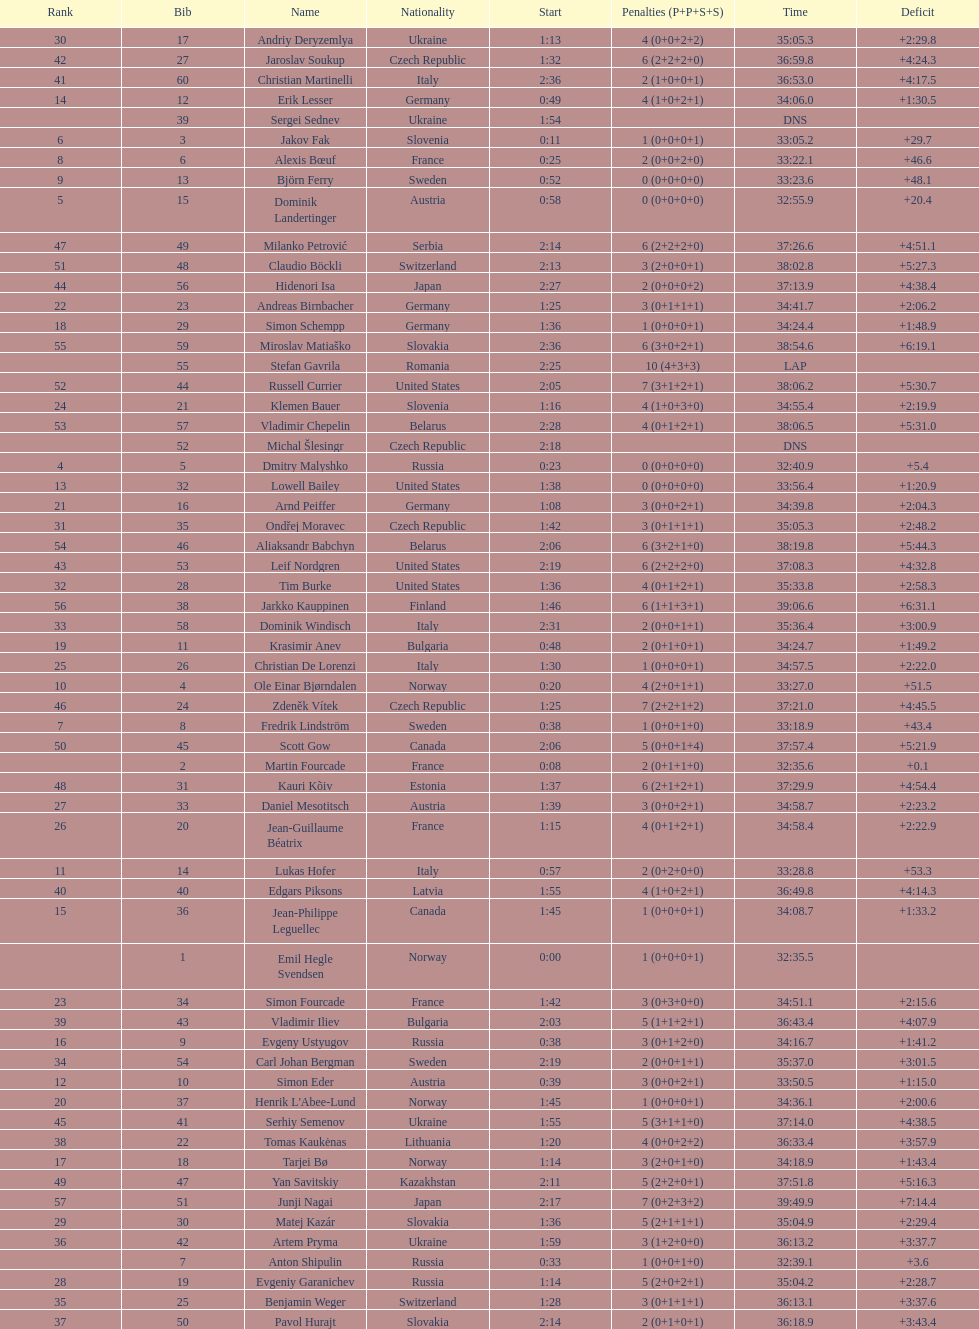How many penalties did germany get all together? 11. 